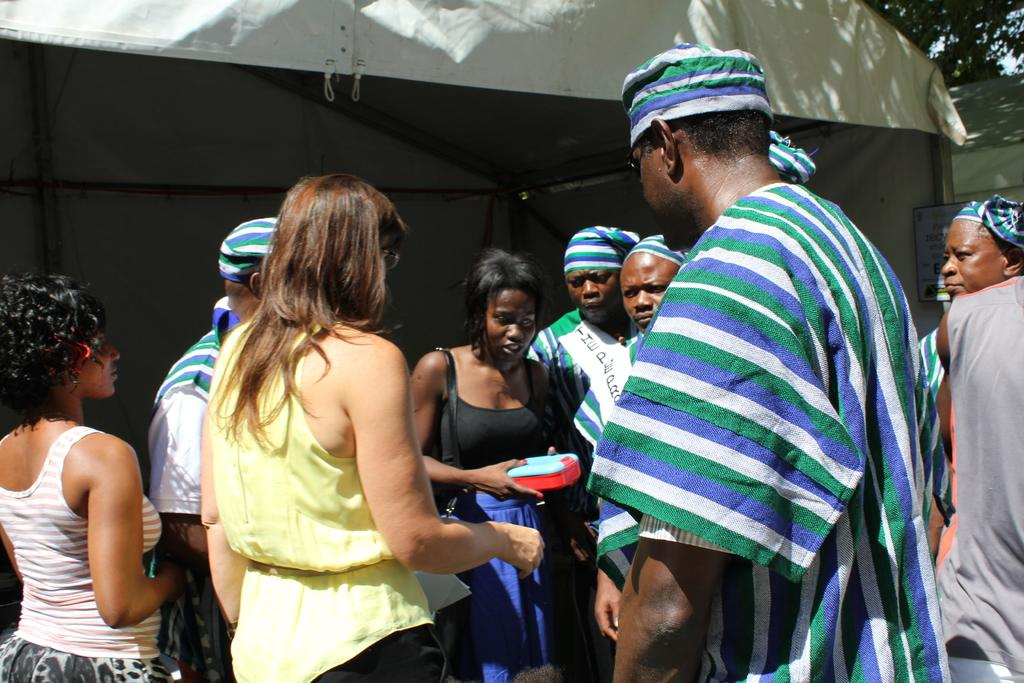What type of clothing accessories can be seen in the image? There are caps in the image. What type of container is visible in the image? There is a bag and a box in the image. What type of shelter is present in the image? There is a tent in the image. What type of display is present in the image? There is a poster in the image. What type of structural elements can be seen in the image? There are rods in the image. What type of objects are present in the image? There are objects in the image, including caps, a bag, a box, a tent, a poster, and rods. Who is present in the image? There is a group of people standing in the image. What type of natural scenery is visible in the background of the image? There are trees in the background of the image. What type of arithmetic problem can be solved using the rods in the image? The rods in the image do not appear to be related to arithmetic, and therefore no such problem can be solved using them. Can you see a snake slithering through the trees in the background of the image? There is no snake visible in the image, only trees in the background. What type of street is visible in the image? There is no street visible in the image; it features a group of people, a tent, a poster, and other objects. 